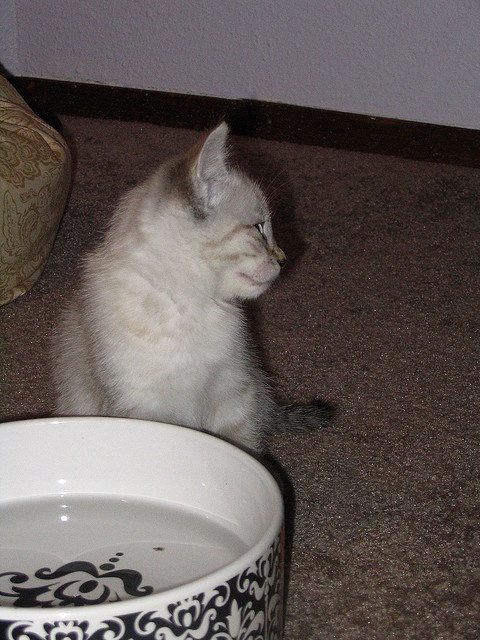Describe the objects in this image and their specific colors. I can see bowl in gray, darkgray, lightgray, and black tones and cat in gray, darkgray, and black tones in this image. 